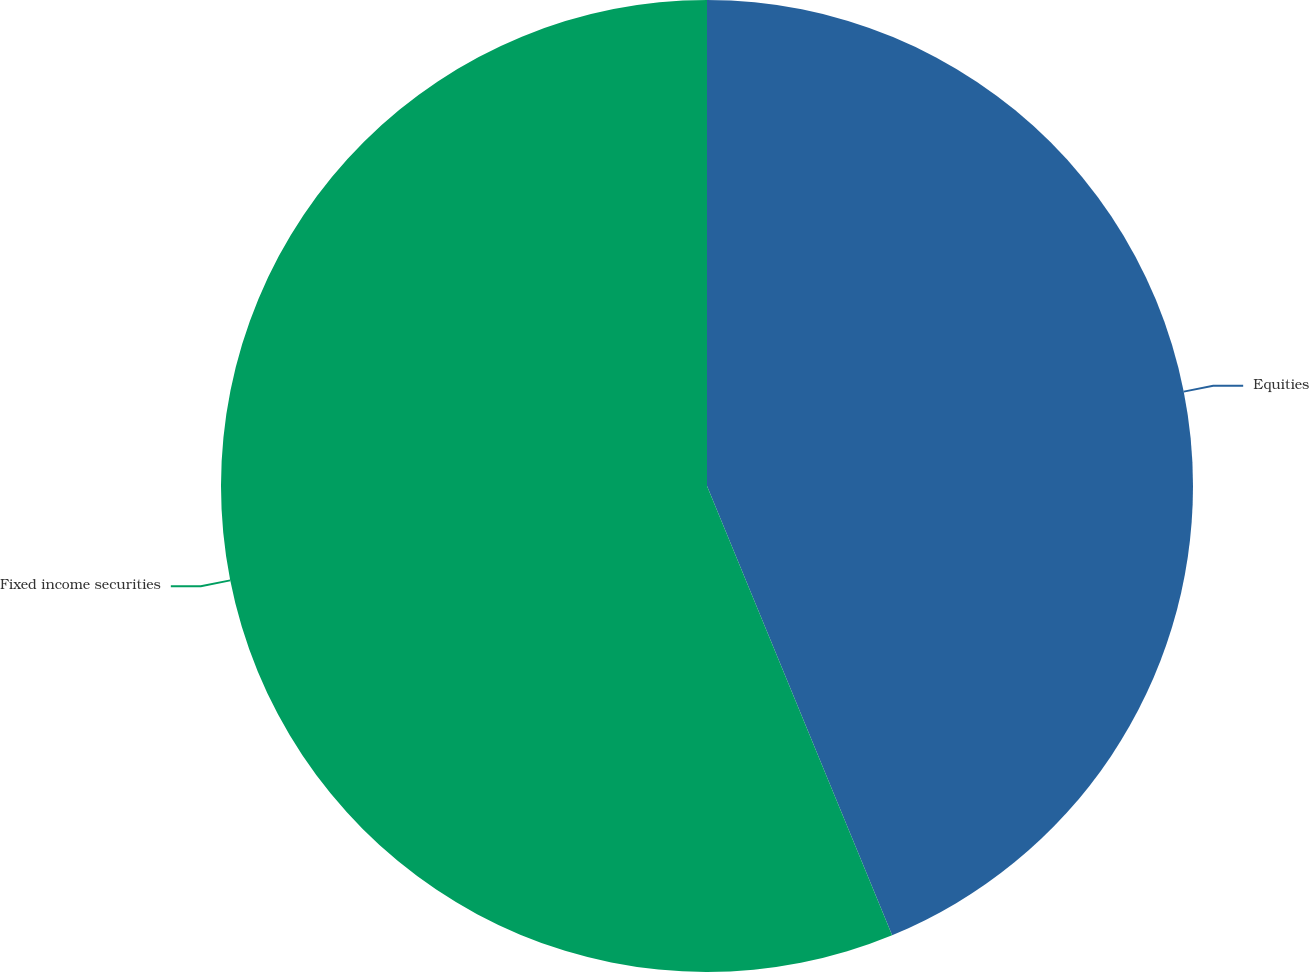<chart> <loc_0><loc_0><loc_500><loc_500><pie_chart><fcel>Equities<fcel>Fixed income securities<nl><fcel>43.78%<fcel>56.22%<nl></chart> 